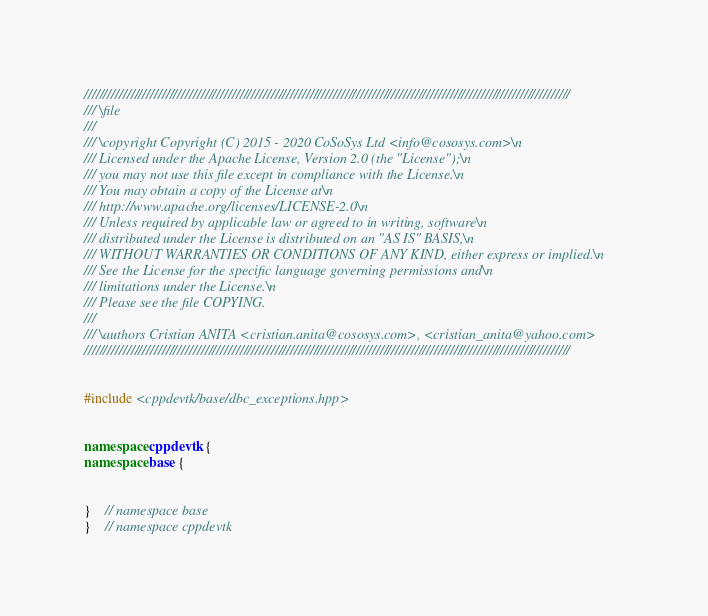<code> <loc_0><loc_0><loc_500><loc_500><_C++_>/////////////////////////////////////////////////////////////////////////////////////////////////////////////////////////////
/// \file
///
/// \copyright Copyright (C) 2015 - 2020 CoSoSys Ltd <info@cososys.com>\n
/// Licensed under the Apache License, Version 2.0 (the "License");\n
/// you may not use this file except in compliance with the License.\n
/// You may obtain a copy of the License at\n
/// http://www.apache.org/licenses/LICENSE-2.0\n
/// Unless required by applicable law or agreed to in writing, software\n
/// distributed under the License is distributed on an "AS IS" BASIS,\n
/// WITHOUT WARRANTIES OR CONDITIONS OF ANY KIND, either express or implied.\n
/// See the License for the specific language governing permissions and\n
/// limitations under the License.\n
/// Please see the file COPYING.
///
/// \authors Cristian ANITA <cristian.anita@cososys.com>, <cristian_anita@yahoo.com>
/////////////////////////////////////////////////////////////////////////////////////////////////////////////////////////////


#include <cppdevtk/base/dbc_exceptions.hpp>


namespace cppdevtk {
namespace base {


}	// namespace base
}	// namespace cppdevtk
</code> 